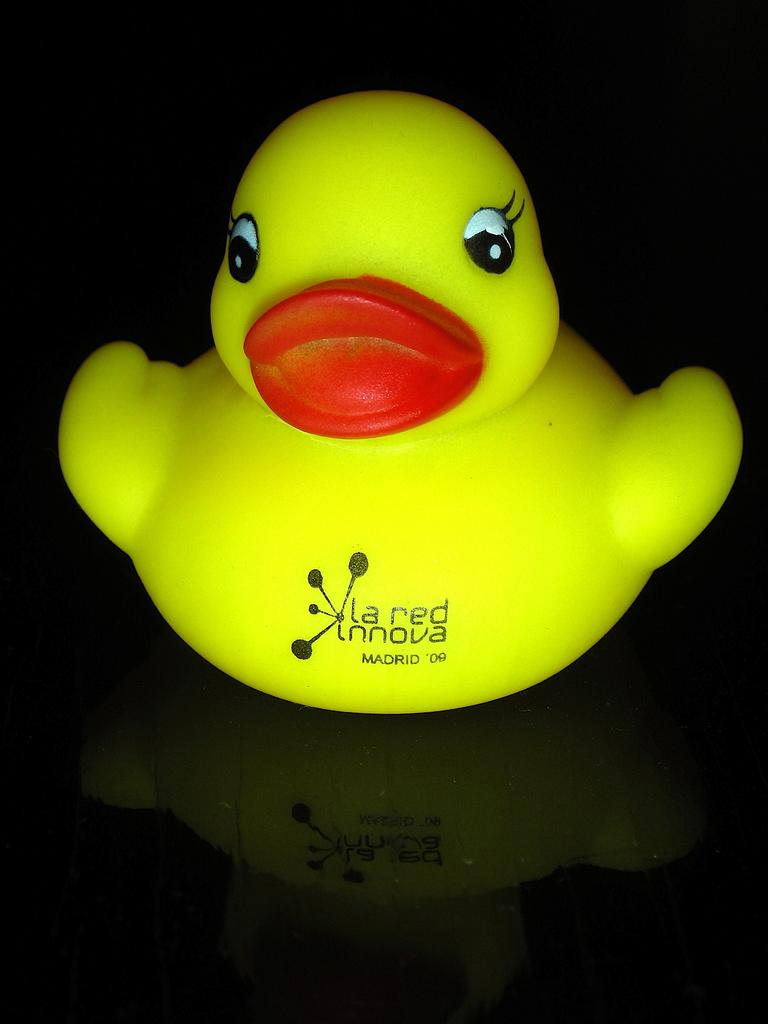What type of toy is in the center of the image? There is a duck toy in the center of the image. Where is the duck toy located? The duck toy is on a table. What type of rhythm does the vegetable unit in the image follow? There is no vegetable or unit present in the image; it only features a duck toy on a table. 